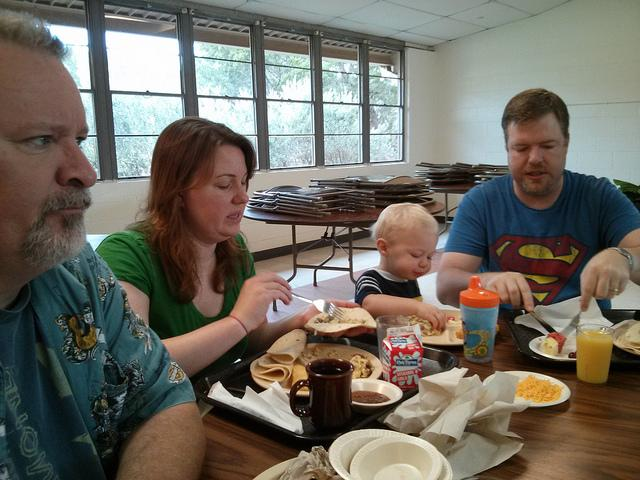What did the man with an S on his shirt likely read when he was young?

Choices:
A) bible
B) poe
C) comic books
D) edith wharton comic books 